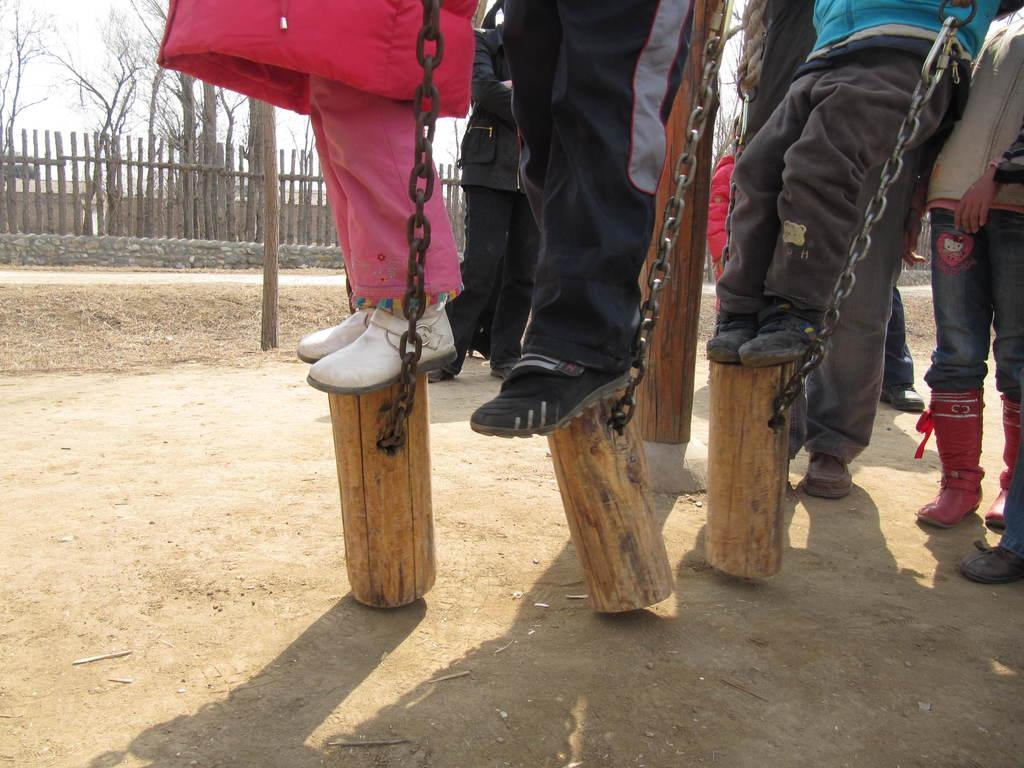What are the persons in the image doing? The persons in the image are standing on logs. How are the logs connected or secured? The logs are tied with chains. What can be seen in the background of the image? In the background, there are sticks, a fence, trees, and the sky. What type of hammer is being used by the person in the image? There is no hammer present in the image; the persons are standing on logs tied with chains. What kind of apparel is the person wearing in the image? The provided facts do not mention any specific apparel worn by the persons in the image. 